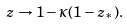<formula> <loc_0><loc_0><loc_500><loc_500>z \rightarrow 1 - \kappa ( 1 - z _ { * } ) .</formula> 